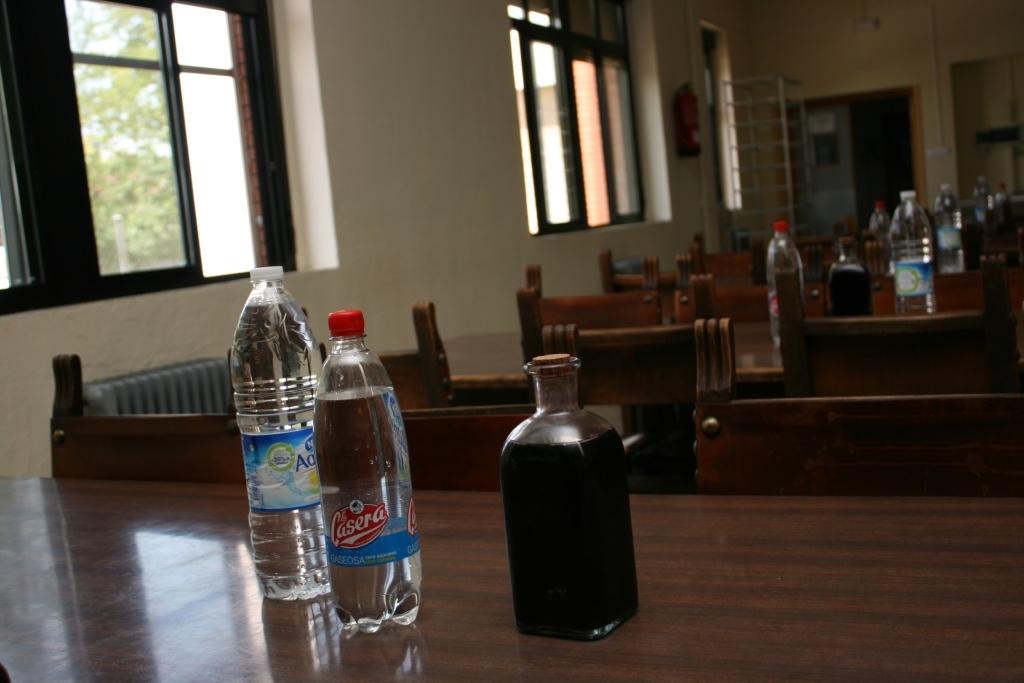What is in the bottle with the red top?
Keep it short and to the point. Casera. 